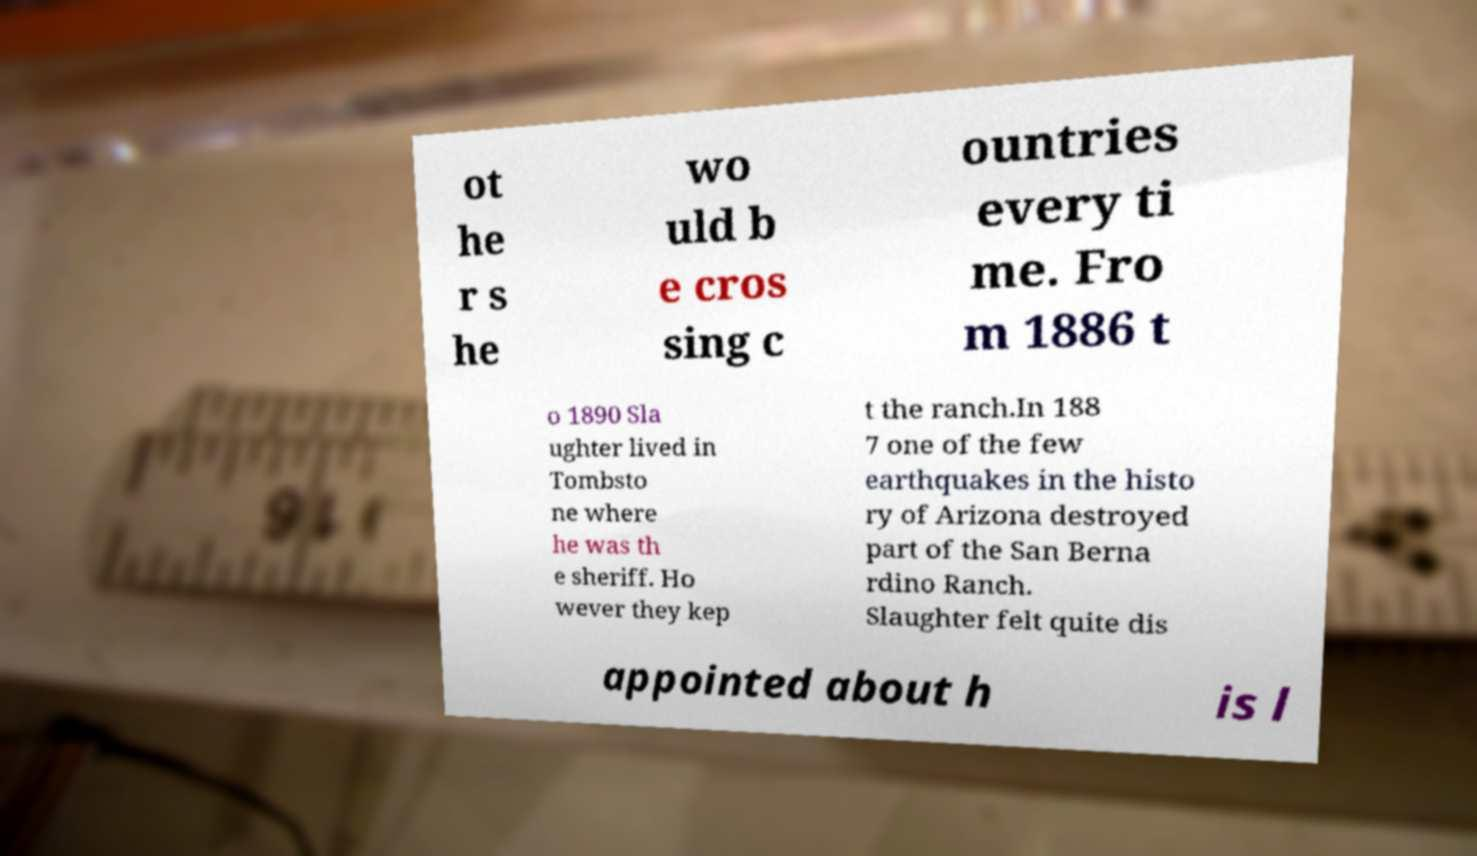There's text embedded in this image that I need extracted. Can you transcribe it verbatim? ot he r s he wo uld b e cros sing c ountries every ti me. Fro m 1886 t o 1890 Sla ughter lived in Tombsto ne where he was th e sheriff. Ho wever they kep t the ranch.In 188 7 one of the few earthquakes in the histo ry of Arizona destroyed part of the San Berna rdino Ranch. Slaughter felt quite dis appointed about h is l 